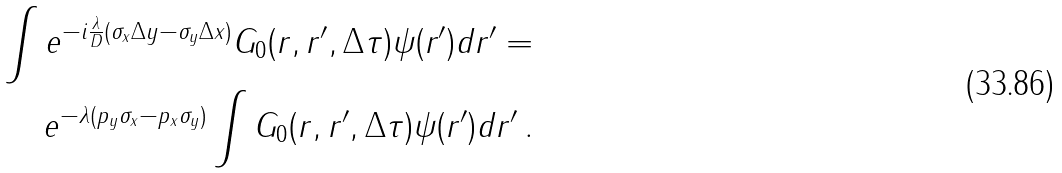Convert formula to latex. <formula><loc_0><loc_0><loc_500><loc_500>\int e ^ { - i \frac { \lambda } { D } ( \sigma _ { x } \Delta y - \sigma _ { y } \Delta x ) } G _ { 0 } ( r , r ^ { \prime } , \Delta \tau ) \psi ( r ^ { \prime } ) d r ^ { \prime } = \\ e ^ { - \lambda ( p _ { y } \sigma _ { x } - p _ { x } \sigma _ { y } ) } \int G _ { 0 } ( r , r ^ { \prime } , \Delta \tau ) \psi ( r ^ { \prime } ) d r ^ { \prime } \, .</formula> 